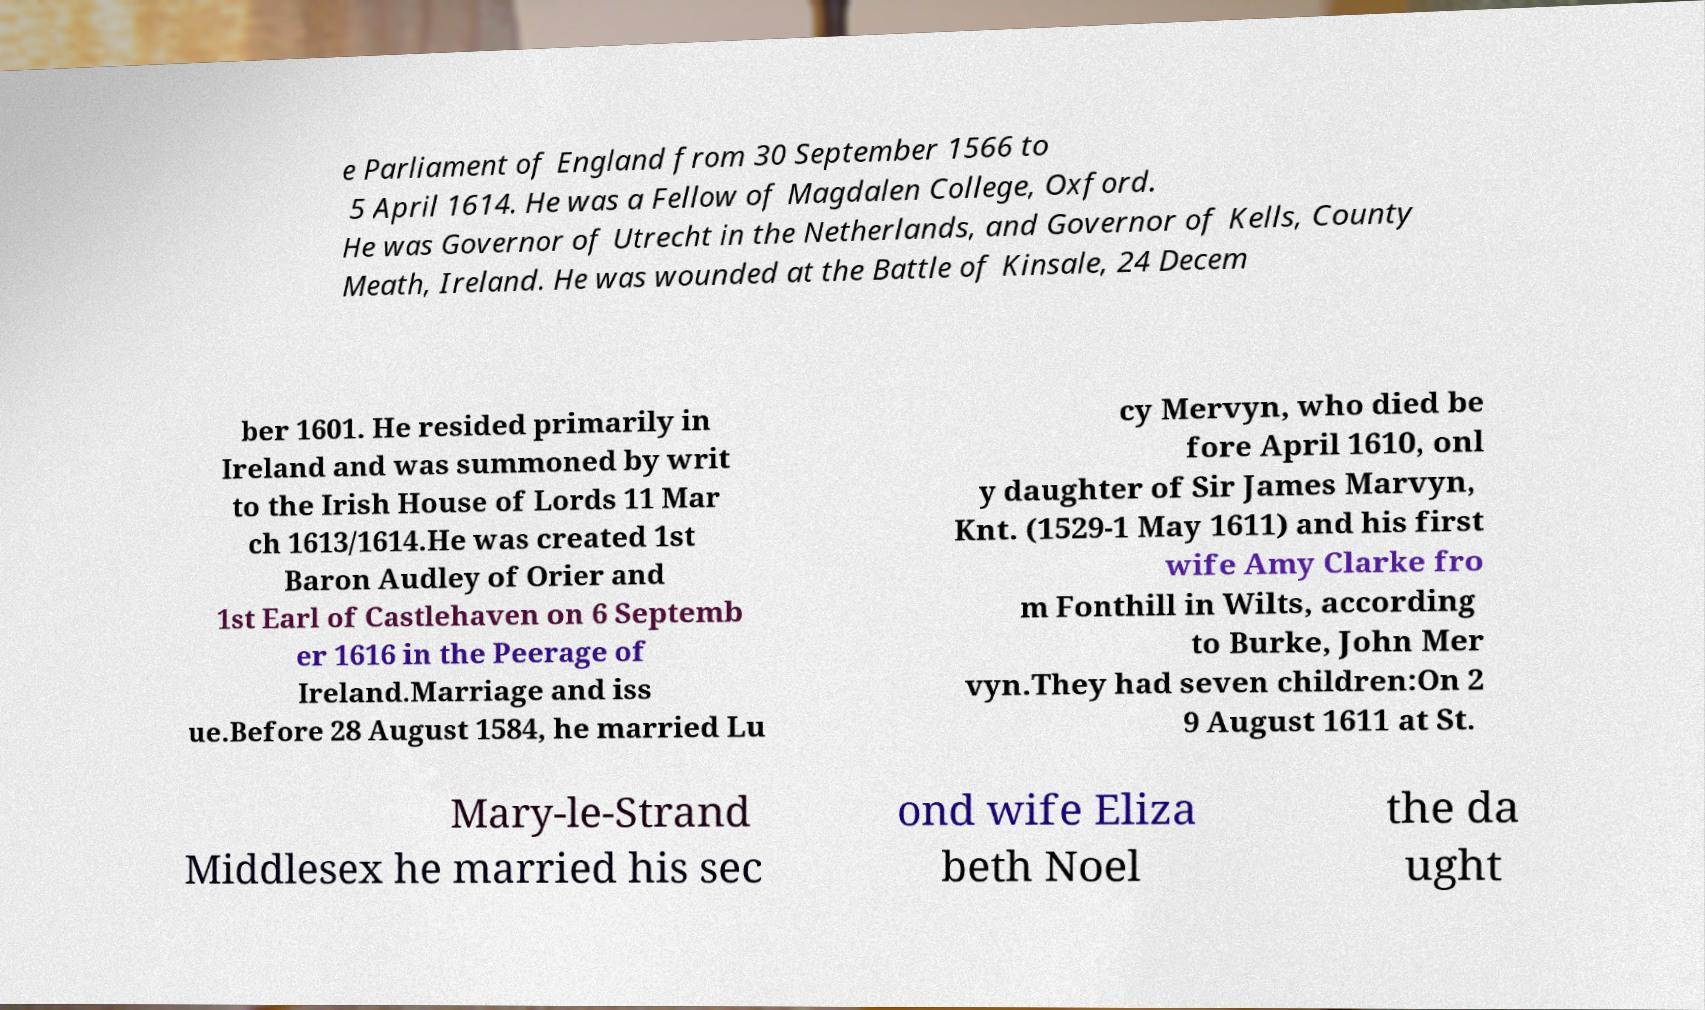Could you assist in decoding the text presented in this image and type it out clearly? e Parliament of England from 30 September 1566 to 5 April 1614. He was a Fellow of Magdalen College, Oxford. He was Governor of Utrecht in the Netherlands, and Governor of Kells, County Meath, Ireland. He was wounded at the Battle of Kinsale, 24 Decem ber 1601. He resided primarily in Ireland and was summoned by writ to the Irish House of Lords 11 Mar ch 1613/1614.He was created 1st Baron Audley of Orier and 1st Earl of Castlehaven on 6 Septemb er 1616 in the Peerage of Ireland.Marriage and iss ue.Before 28 August 1584, he married Lu cy Mervyn, who died be fore April 1610, onl y daughter of Sir James Marvyn, Knt. (1529-1 May 1611) and his first wife Amy Clarke fro m Fonthill in Wilts, according to Burke, John Mer vyn.They had seven children:On 2 9 August 1611 at St. Mary-le-Strand Middlesex he married his sec ond wife Eliza beth Noel the da ught 